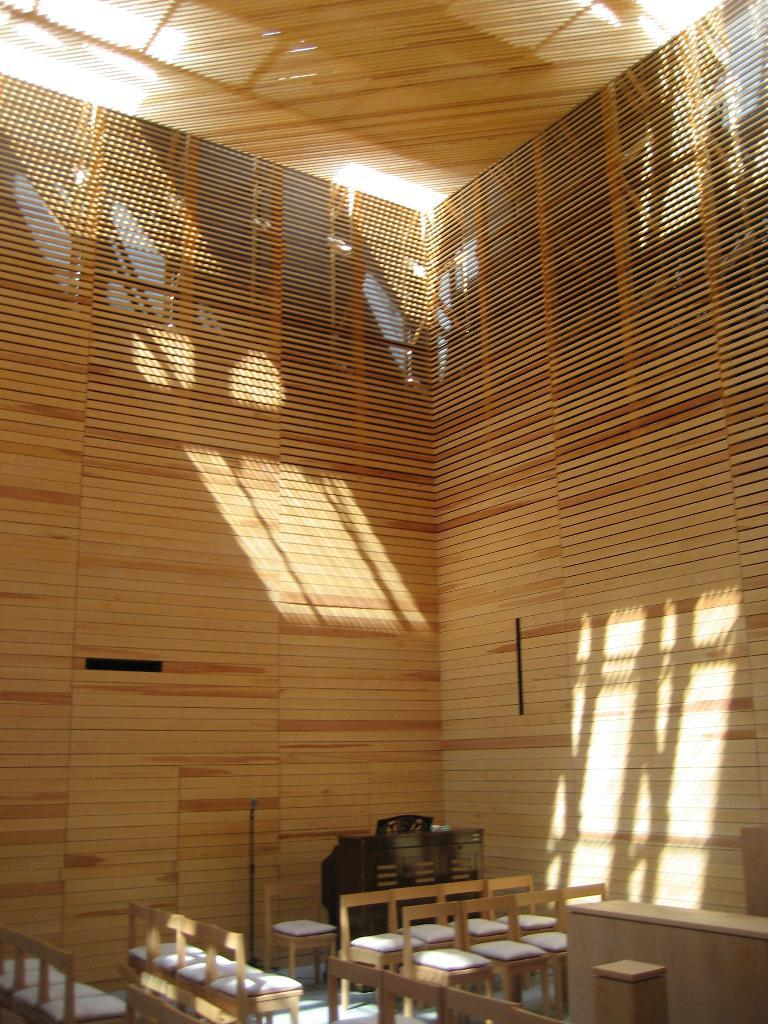What type of furniture can be seen in the image? There are chairs and a table in the image. What other object is present in the image? There is a wooden drawer in the image. What material is used for the background of the image? The background of the image appears to be made of wood. How many planes are parked on the farm in the image? There are no planes or farms present in the image; it features chairs, a table, and a wooden drawer. 